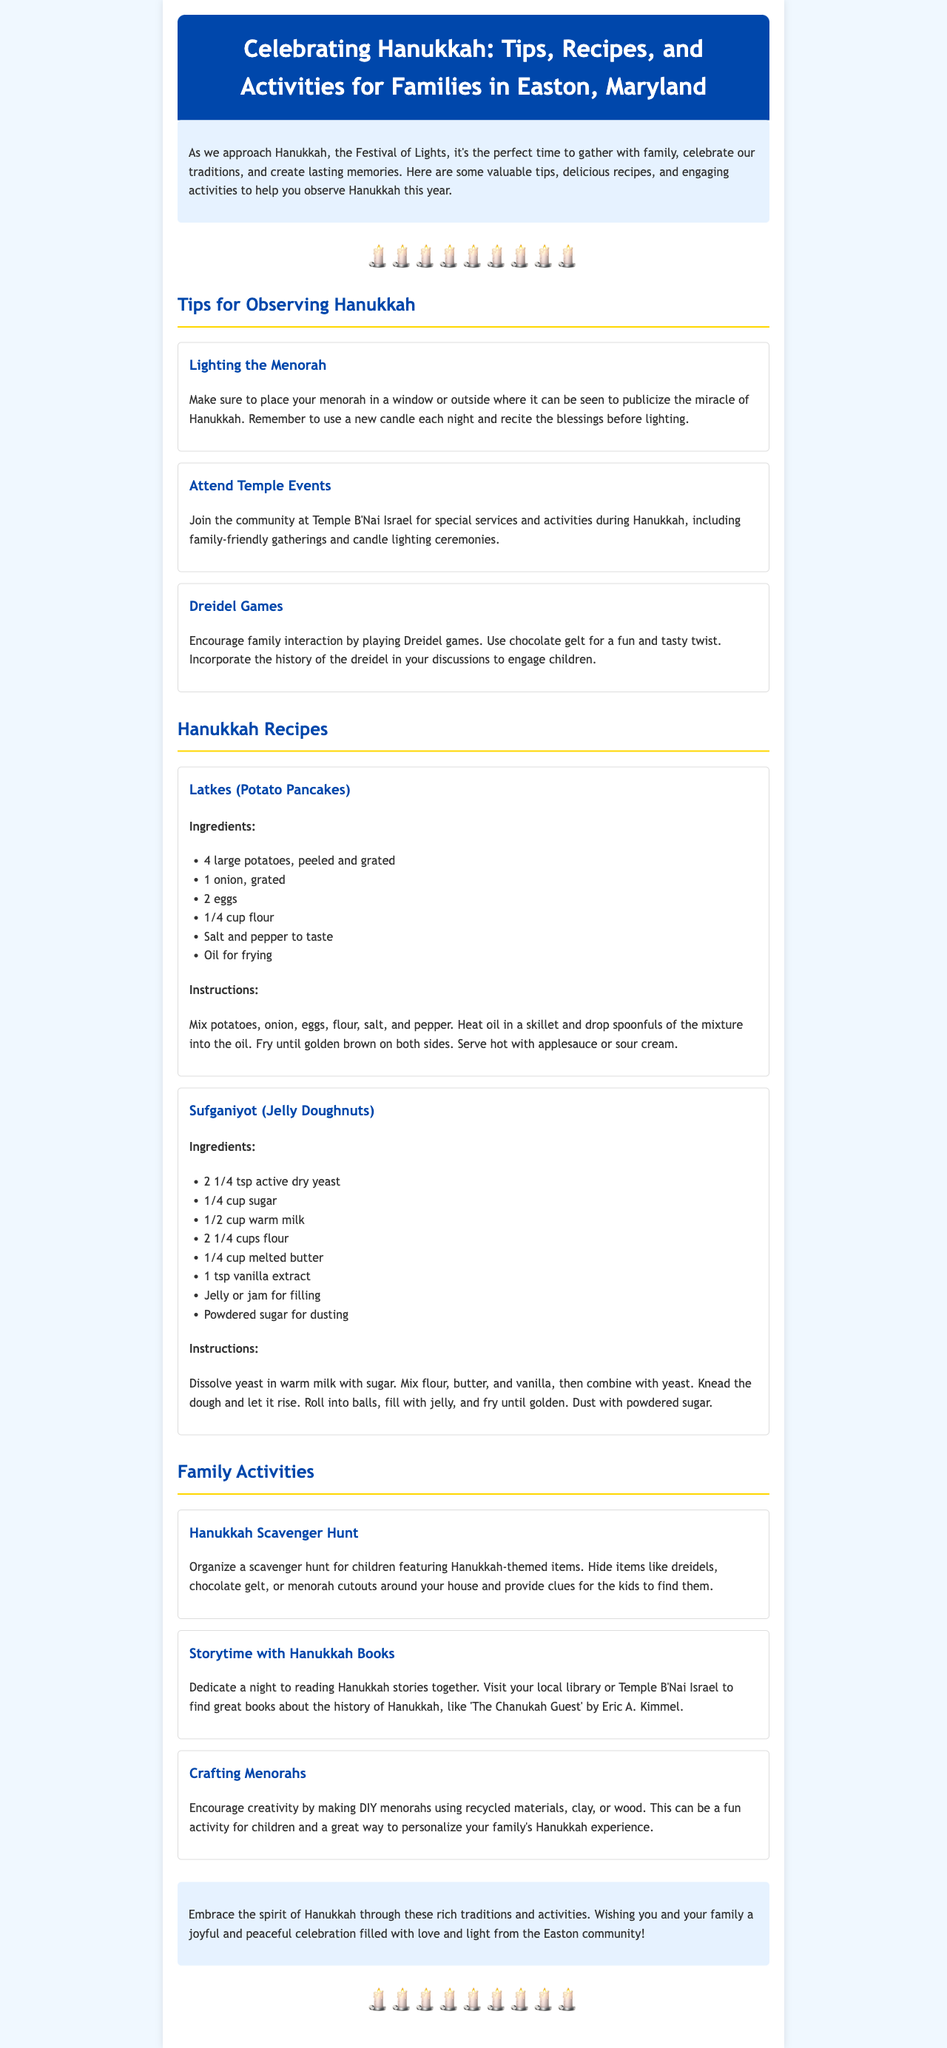What is the title of the newsletter? The title is explicitly stated at the beginning of the document.
Answer: Celebrating Hanukkah: Tips, Recipes, and Activities for Families in Easton, Maryland How many tips are provided for observing Hanukkah? The document lists a specific number of tips in one section.
Answer: Three What is one traditional food mentioned in the recipes? The recipes section includes specific traditional foods related to Hanukkah.
Answer: Latkes What activity involves reading books about Hanukkah? The activities section describes a specific family activity that includes books.
Answer: Storytime with Hanukkah Books Where can families attend special events during Hanukkah? The tips section mentions a specific community location for events.
Answer: Temple B'Nai Israel Which game is suggested for family interaction during Hanukkah? The document mentions a particular game that encourages family engagement.
Answer: Dreidel games What is used for filling in the sufganiyot? The recipe for sufganiyot specifies an ingredient that serves as filling.
Answer: Jelly or jam What type of hunt is suggested as a family activity? The document outlines a specific activity that involves searching for items.
Answer: Hanukkah Scavenger Hunt How should the menorah be placed to publicize Hanukkah? The tips for observing Hanukkah provide a specific guideline regarding placement.
Answer: In a window or outside 